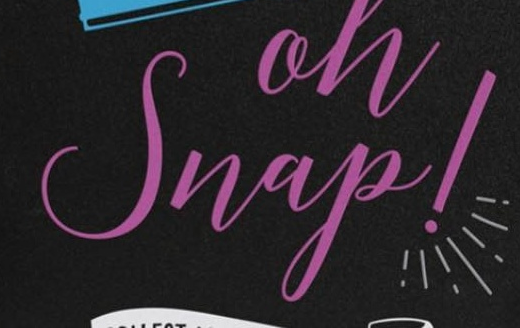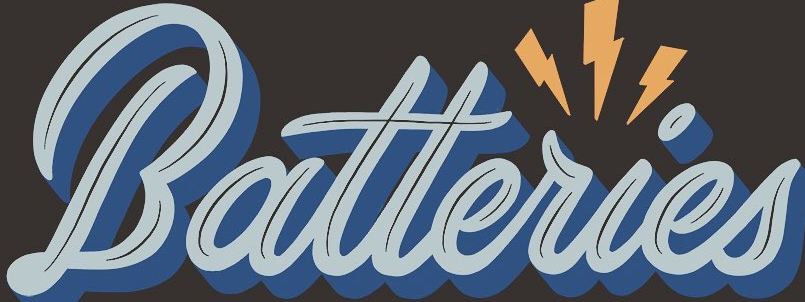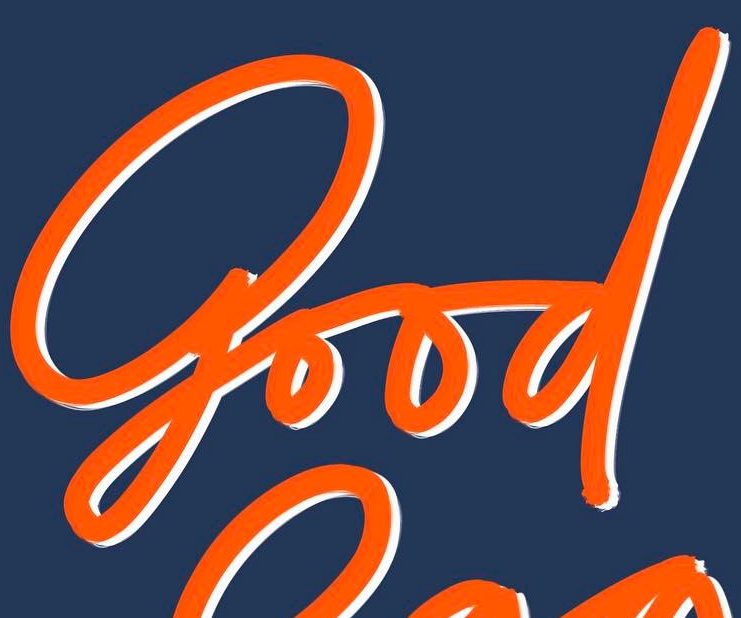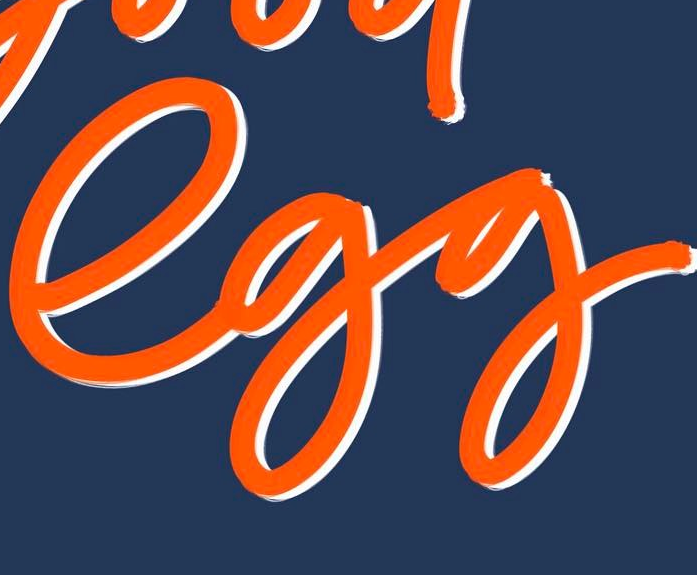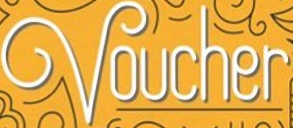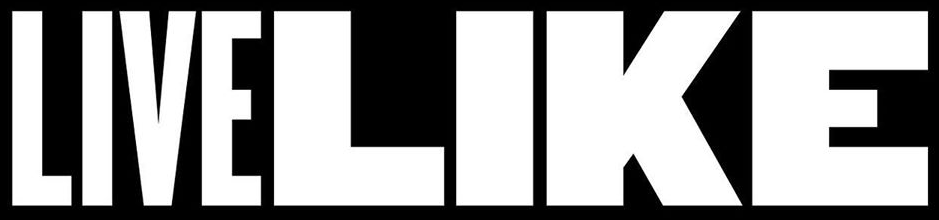What words can you see in these images in sequence, separated by a semicolon? Snap!; Batteries; good; egg; Voucher; LIVELIKE 